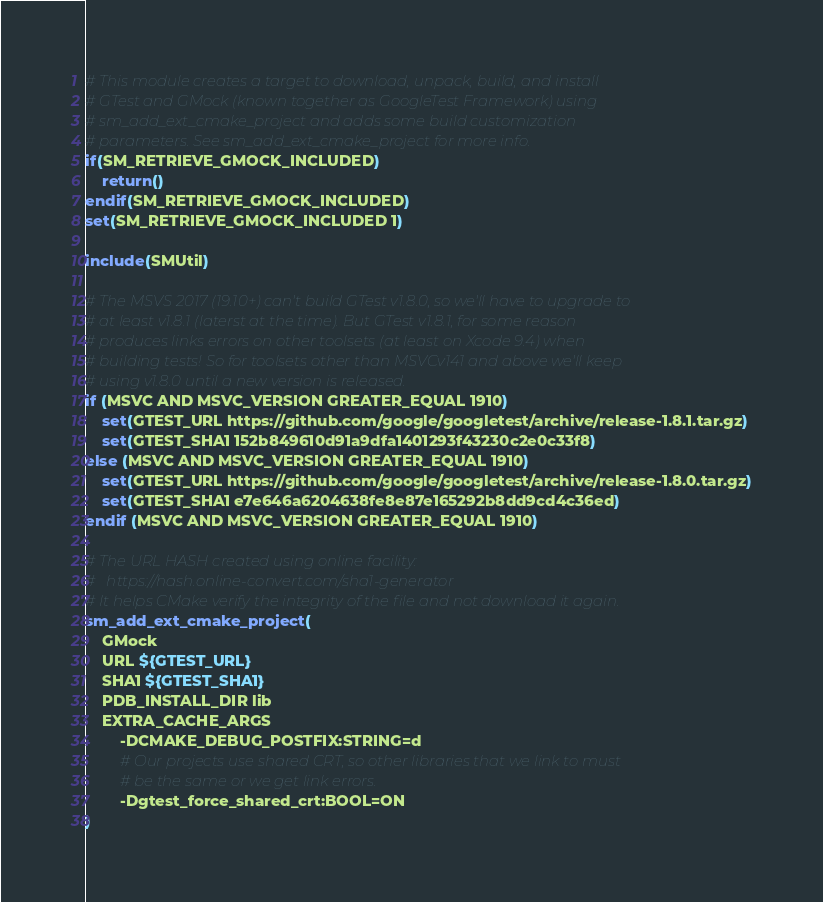Convert code to text. <code><loc_0><loc_0><loc_500><loc_500><_CMake_># This module creates a target to download, unpack, build, and install
# GTest and GMock (known together as GoogleTest Framework) using
# sm_add_ext_cmake_project and adds some build customization
# parameters. See sm_add_ext_cmake_project for more info.
if(SM_RETRIEVE_GMOCK_INCLUDED)
    return()
endif(SM_RETRIEVE_GMOCK_INCLUDED)
set(SM_RETRIEVE_GMOCK_INCLUDED 1)

include(SMUtil)

# The MSVS 2017 (19.10+) can't build GTest v1.8.0, so we'll have to upgrade to
# at least v1.8.1 (laterst at the time). But GTest v1.8.1, for some reason
# produces links errors on other toolsets (at least on Xcode 9.4) when
# building tests! So for toolsets other than MSVCv141 and above we'll keep
# using v1.8.0 until a new version is released.
if (MSVC AND MSVC_VERSION GREATER_EQUAL 1910)
    set(GTEST_URL https://github.com/google/googletest/archive/release-1.8.1.tar.gz)
    set(GTEST_SHA1 152b849610d91a9dfa1401293f43230c2e0c33f8)
else (MSVC AND MSVC_VERSION GREATER_EQUAL 1910)
    set(GTEST_URL https://github.com/google/googletest/archive/release-1.8.0.tar.gz)
    set(GTEST_SHA1 e7e646a6204638fe8e87e165292b8dd9cd4c36ed)
endif (MSVC AND MSVC_VERSION GREATER_EQUAL 1910)

# The URL HASH created using online facility:
# 	https://hash.online-convert.com/sha1-generator
# It helps CMake verify the integrity of the file and not download it again.
sm_add_ext_cmake_project(
    GMock
    URL ${GTEST_URL}
    SHA1 ${GTEST_SHA1}
    PDB_INSTALL_DIR lib
    EXTRA_CACHE_ARGS
        -DCMAKE_DEBUG_POSTFIX:STRING=d
        # Our projects use shared CRT, so other libraries that we link to must
        # be the same or we get link errors.
        -Dgtest_force_shared_crt:BOOL=ON
)
</code> 